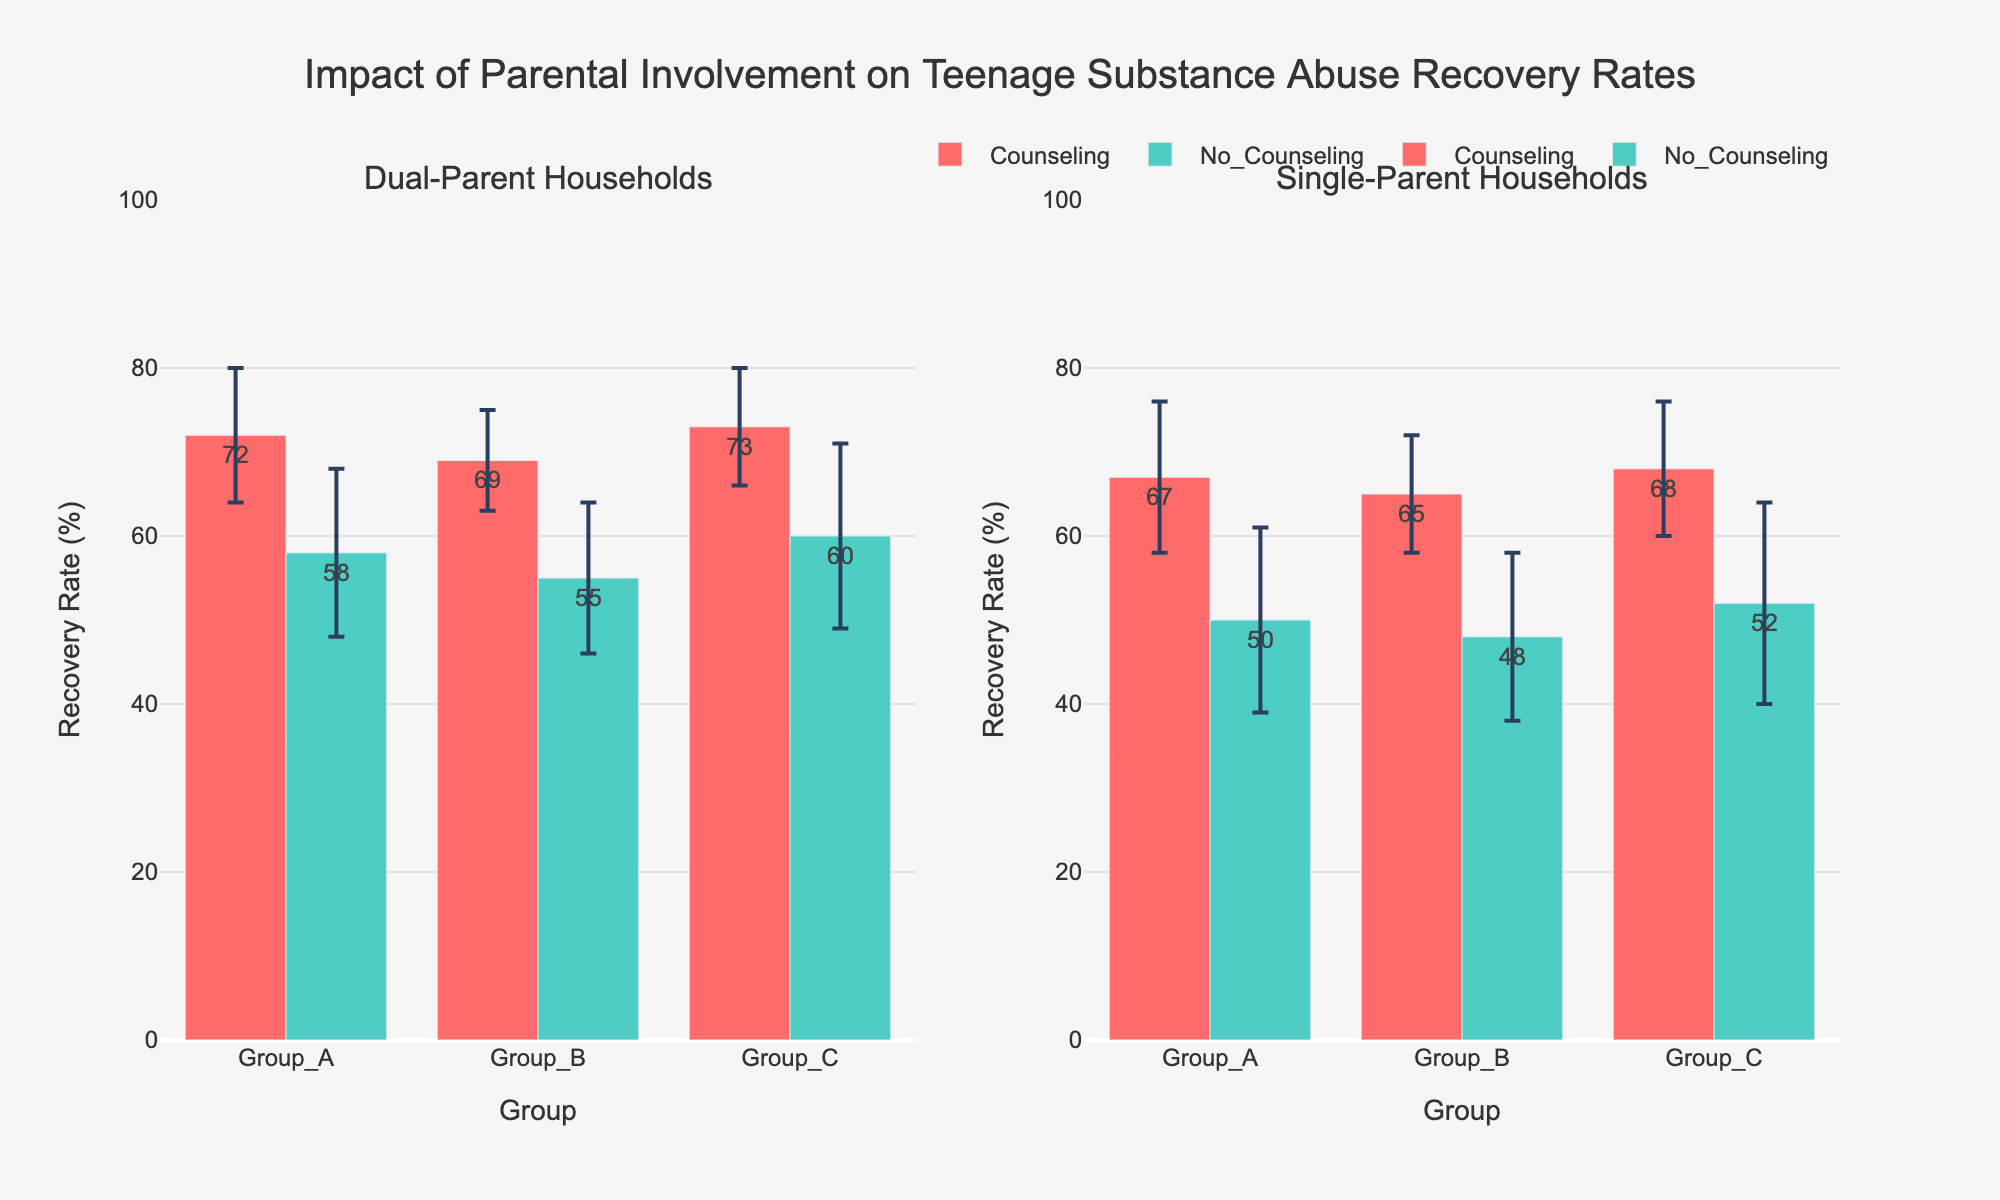Which household type has the highest average recovery rate in group C with counseling? To find this, look at the bars representing group C with counseling for both dual-parent and single-parent households. The dual-parent household has a recovery rate of 73%, and the single-parent household has a recovery rate of 68%. Since 73% > 68%, dual-parent household has the highest recovery rate.
Answer: Dual-Parent household Which group in dual-parent households has the lowest recovery rate with no counseling? Look at the bars representing groups A, B, and C with no counseling in the dual-parent household subplot. Group B has the lowest rate of 55%.
Answer: Group B What is the average recovery rate across all groups for single-parent households with counseling? The recovery rates for groups A, B, and C with counseling in single-parent households are 67%, 65%, and 68%. Sum these rates and divide by the number of groups: (67 + 65 + 68) / 3 = 200 / 3 ≈ 66.7%.
Answer: 66.7% How much higher is the recovery rate for group B in dual-parent households with counseling compared to single-parent households with counseling? Compare the bars for group B with counseling in dual-parent households (69%) and single-parent households (65%). The difference is 69% - 65% = 4%.
Answer: 4% Which type of household and counseling combination leads to the highest recovery rate overall? Look through all the bars representing recovery rates and find the highest value. It is 73% for dual-parent households with counseling, group C.
Answer: Dual-Parent with Counseling, Group C What is the range of recovery rates for dual-parent households with no counseling? Identify the minimum and maximum recovery rates for groups A, B, and C with no counseling: 55% (Group B) and 60% (Group C). The range is 60% - 55% = 5%.
Answer: 5% Which household type shows a larger standard deviation in recovery rates for group A with no counseling? Compare the standard deviations for group A with no counseling in both household types: dual-parent (10) and single-parent (11). Single-parent has a larger standard deviation.
Answer: Single-Parent Is there a consistent trend that counseling increases the recovery rate across both household types? Compare recovery rates with and without counseling within each household type. For both dual-parent and single-parent households, the recovery rates with counseling are higher than those without counseling (e.g., for single-parent households, 67% vs. 50% for group A). This suggests a consistent positive trend.
Answer: Yes Which group in single-parent households shows the most variability in recovery rates with no counseling? Look at the error bars representing standard deviations for groups A, B, and C in single-parent households with no counseling. Group C has the largest error bar, indicating the most variability with a standard deviation of 12.
Answer: Group C 